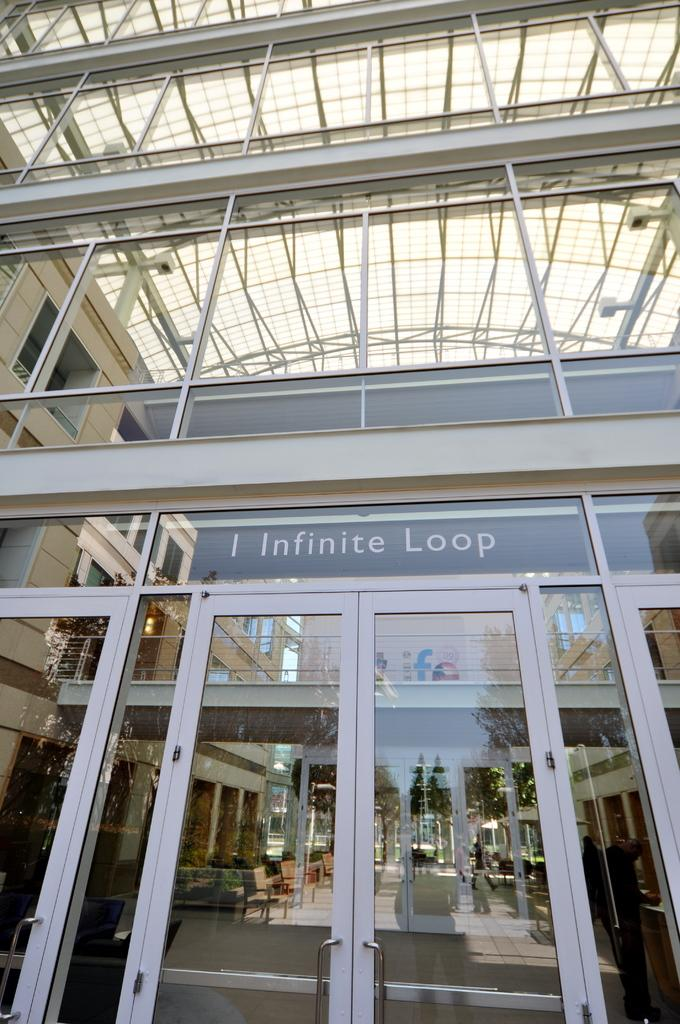What type of structure is present in the image? There is a building in the image. What can be seen at the bottom of the image? There are doors at the bottom of the image. What is visible through the doors? A table and chairs are visible through the doors. What can be seen in the reflection in the image? The sky, flags, and a person are visible in the reflection. Where is the hydrant located in the image? There is no hydrant present in the image. Can you describe the cellar in the image? There is no cellar mentioned or visible in the image. 